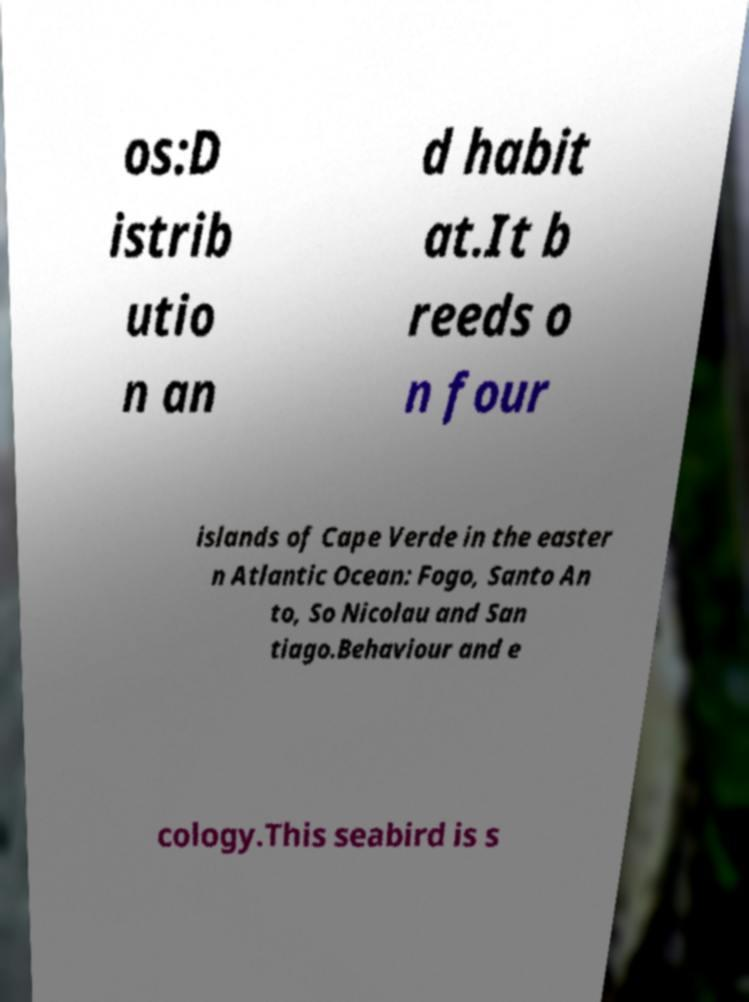Can you read and provide the text displayed in the image?This photo seems to have some interesting text. Can you extract and type it out for me? os:D istrib utio n an d habit at.It b reeds o n four islands of Cape Verde in the easter n Atlantic Ocean: Fogo, Santo An to, So Nicolau and San tiago.Behaviour and e cology.This seabird is s 